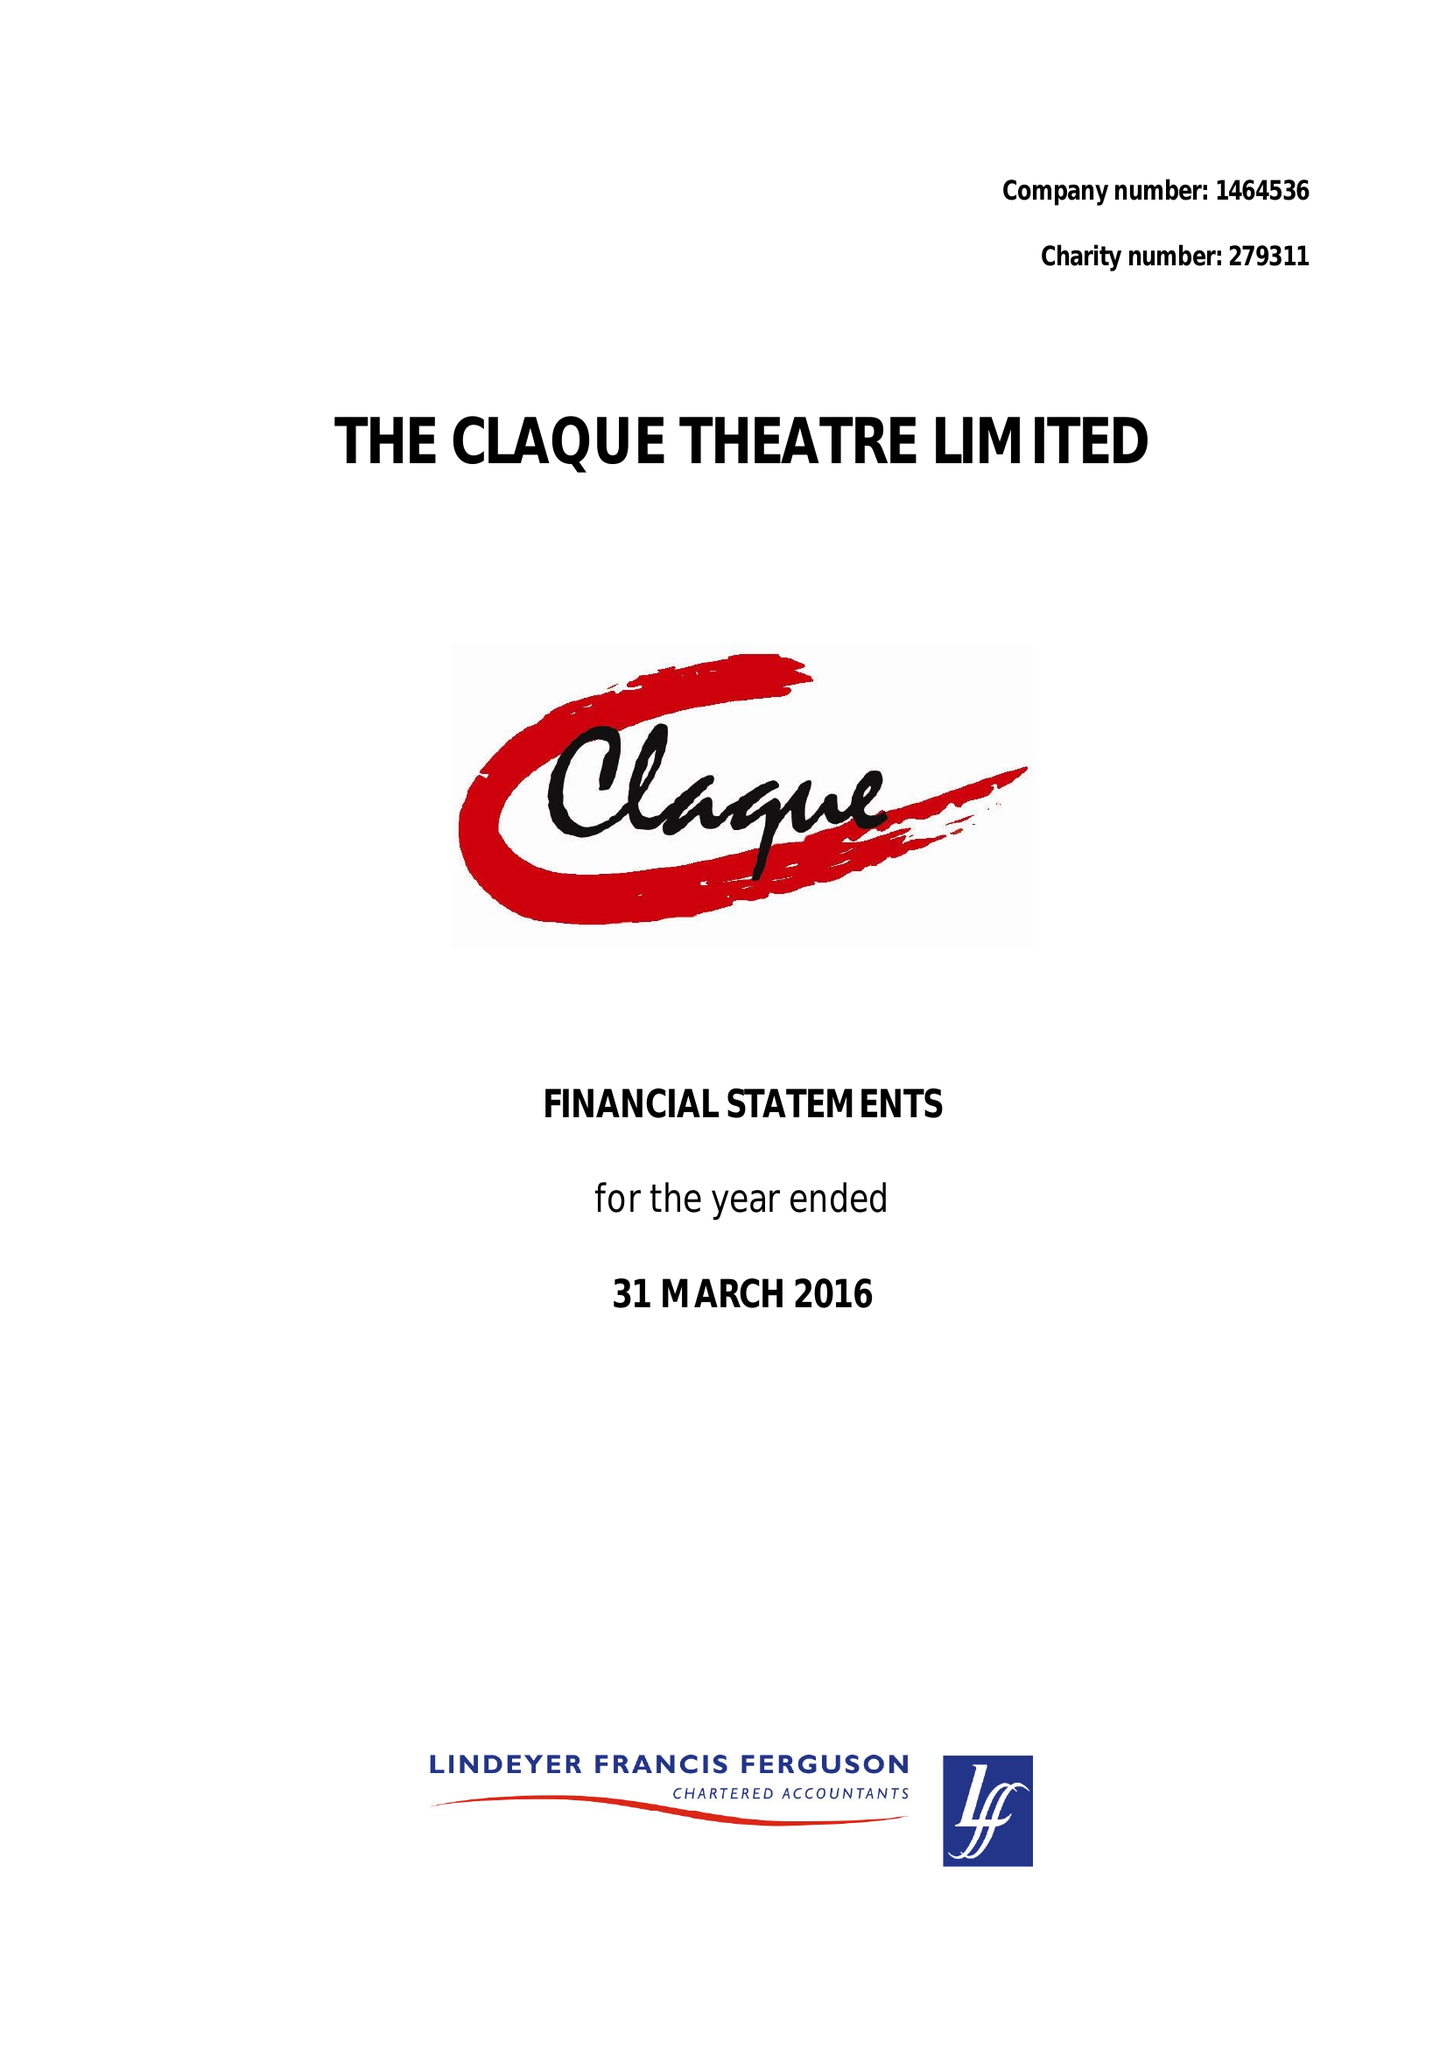What is the value for the address__street_line?
Answer the question using a single word or phrase. 12 APSLEY STREET 